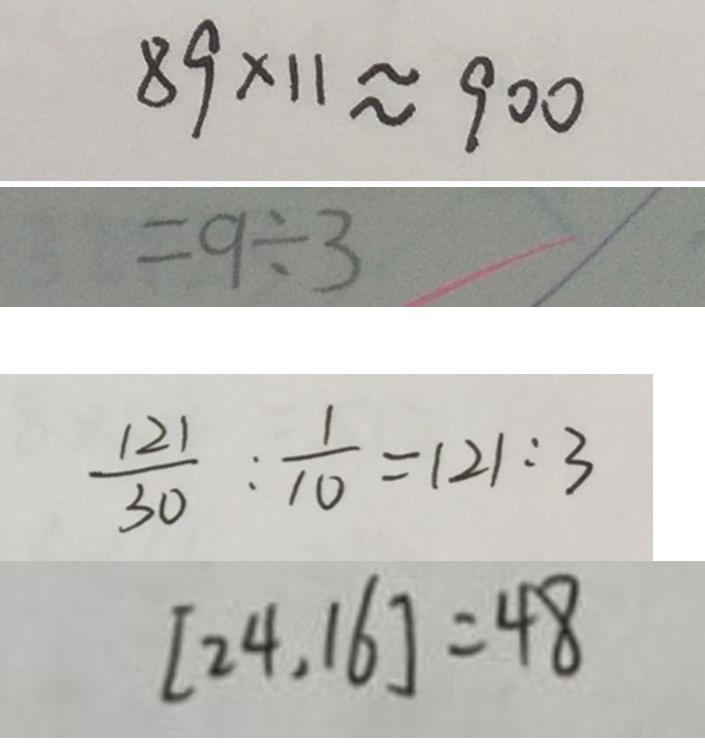<formula> <loc_0><loc_0><loc_500><loc_500>8 9 \times 1 1 \approx 9 0 0 
 = 9 \div 3 
 \frac { 1 2 1 } { 3 0 } : \frac { 1 } { 1 0 } = 1 2 1 : 3 
 [ 2 4 , 1 6 ] = 4 8</formula> 